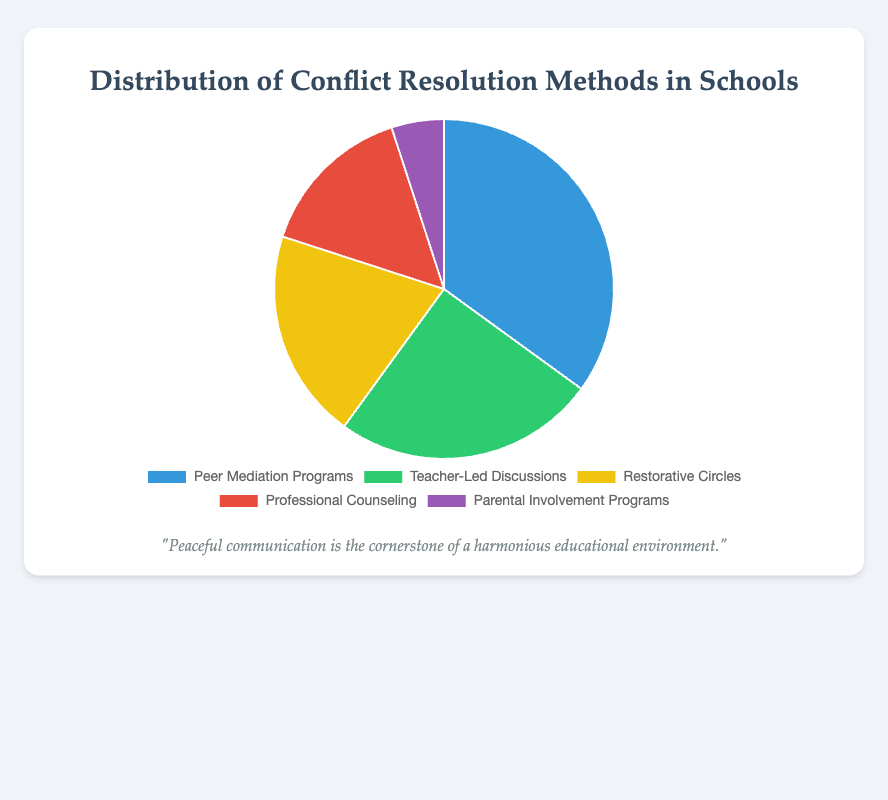Which conflict resolution method is the most common? The pie chart shows the distribution of various conflict resolution methods. The largest segment represents Peer Mediation Programs, which has the highest percentage.
Answer: Peer Mediation Programs What is the combined percentage of Teacher-Led Discussions and Restorative Circles? To find the combined percentage, add the percentages of Teacher-Led Discussions (25%) and Restorative Circles (20%). 25% + 20% = 45%
Answer: 45% Which method has the smallest proportion in the pie chart? The visual shows the smallest segment representing Parental Involvement Programs at 5%.
Answer: Parental Involvement Programs How much larger is the percentage of Peer Mediation Programs compared to Professional Counseling? Subtract the percentage of Professional Counseling (15%) from the percentage of Peer Mediation Programs (35%). 35% - 15% = 20%
Answer: 20% Are Restorative Circles more or less common than Professional Counseling? By comparing the segments, Restorative Circles have a larger section (20%) compared to Professional Counseling (15%).
Answer: More common Which methods together constitute exactly half of the total methods? Add the percentages of methods to find which combination equals 50%. Teacher-Led Discussions (25%) and Restorative Circles (20%) together make 45%, but Peer Mediation Programs (35%) and Professional Counseling (15%) together make 50%.
Answer: Peer Mediation Programs and Professional Counseling What is the difference in percentage between the most and least common methods? Subtract the percentage of Parental Involvement Programs (5%) from Peer Mediation Programs (35%). 35% - 5% = 30%
Answer: 30% What color is the segment representing the Restorative Circles? The visual representation uses color coding, and Restorative Circles is shown in yellow.
Answer: Yellow Does Teacher-Led Discussions account for more or less than a quarter of the total methods? The percentage of Teacher-Led Discussions is 25%, which is exactly one quarter (25%) of the total.
Answer: Exactly a quarter What is the average percentage of all the conflict resolution methods represented? To find the average, sum all percentages (35% + 25% + 20% + 15% + 5%) and divide by the number of methods (5). (35 + 25 + 20 + 15 + 5) / 5 = 100 / 5 = 20%
Answer: 20% 